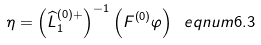<formula> <loc_0><loc_0><loc_500><loc_500>\eta = \left ( \widehat { L } _ { 1 } ^ { \left ( 0 \right ) + } \right ) ^ { - 1 } \left ( F ^ { \left ( 0 \right ) } \varphi \right ) \ e q n u m { 6 . 3 }</formula> 